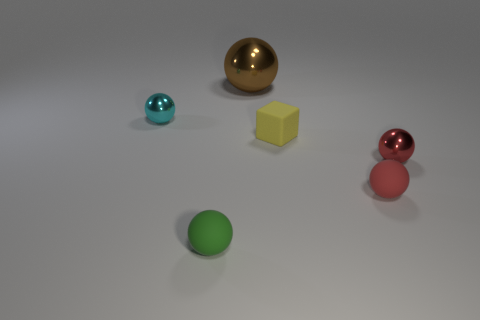Add 1 tiny blue rubber objects. How many objects exist? 7 Subtract all tiny green matte balls. How many balls are left? 4 Subtract all spheres. How many objects are left? 1 Subtract all red spheres. How many spheres are left? 3 Subtract 3 spheres. How many spheres are left? 2 Add 2 tiny green rubber objects. How many tiny green rubber objects exist? 3 Subtract 0 purple cylinders. How many objects are left? 6 Subtract all blue cubes. Subtract all blue cylinders. How many cubes are left? 1 Subtract all brown cubes. How many green spheres are left? 1 Subtract all large blue shiny spheres. Subtract all tiny red shiny things. How many objects are left? 5 